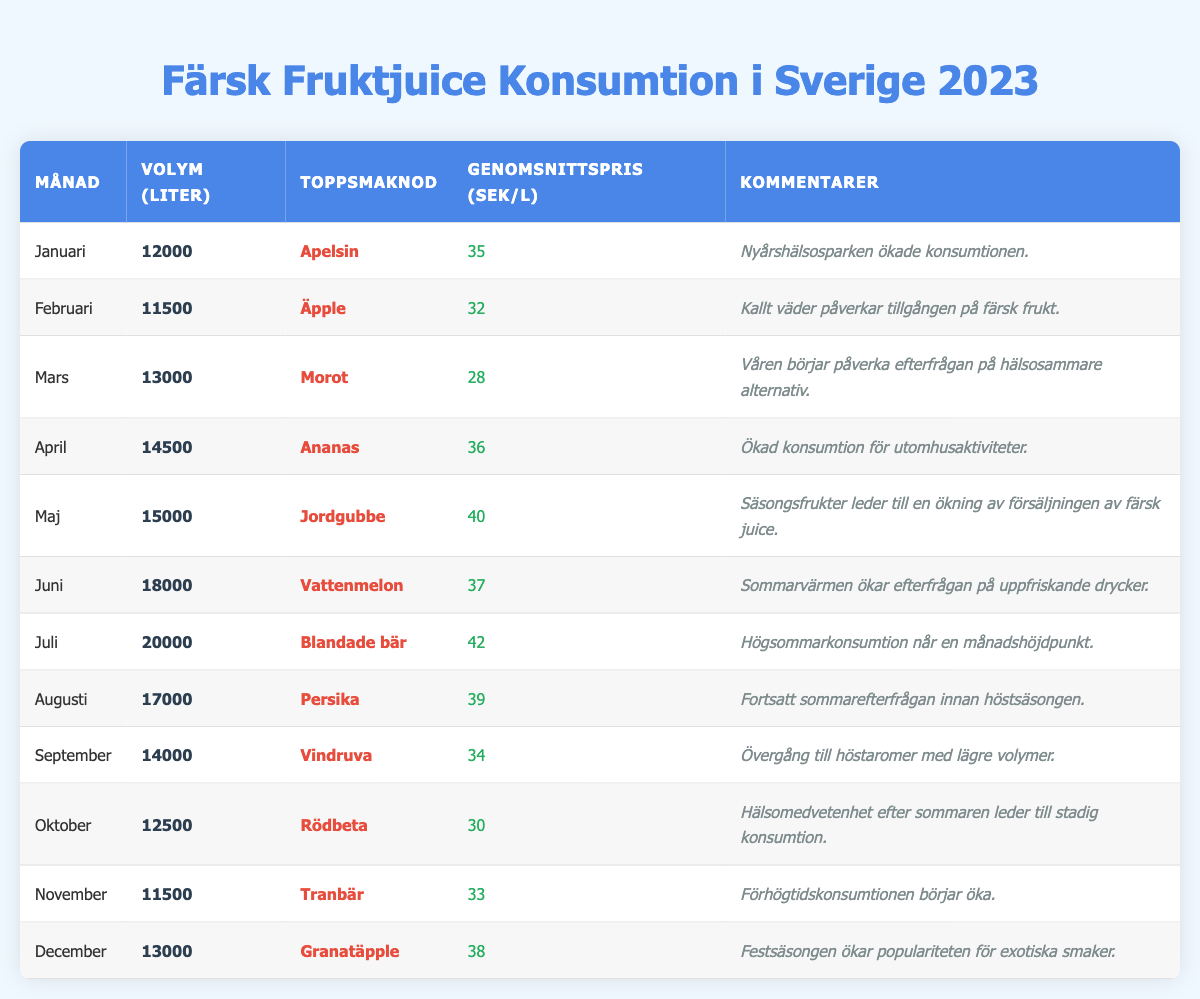What's the top flavor of fruit juice consumed in June? According to the table, the month of June lists "Watermelon" as the top flavor.
Answer: Watermelon How much fresh fruit juice was consumed in April? The table shows that the volume of fresh fruit juice consumed in April was 14,500 liters.
Answer: 14,500 liters What was the average price per liter of juice in October? The table indicates the average price per liter in October was 30 SEK.
Answer: 30 SEK Which month saw the highest juice consumption in terms of volume? Looking at the data, July had the highest consumption with 20,000 liters.
Answer: July What was the average price per liter for fresh fruit juice from January to March? To find the average, calculate the total price for January (35), February (32), and March (28): (35 + 32 + 28) = 95. Then, divide by 3 to get the average: 95 / 3 = approximately 31.67.
Answer: 31.67 SEK Did the consumption of fresh fruit juice increase from June to July? Comparing the volumes, June had 18,000 liters and July had 20,000 liters, so yes, consumption did increase.
Answer: Yes Which flavor was the least popular in February? The table lists "Apple" as the top flavor for February, indicating it was the only one listed for that month, thus it was the least popular overall.
Answer: Apple How much juice was consumed in total for the months of March, April, and May combined? Add the volumes from March (13,000), April (14,500), and May (15,000): 13,000 + 14,500 + 15,000 = 42,500 liters.
Answer: 42,500 liters Was there a trend of increasing prices for fresh fruit juices from January to July? Reviewing the average prices, they are: January (35), February (32), March (28), April (36), May (40), June (37), July (42). The prices initially fluctuated before rising towards July, indicating an upward trend.
Answer: Yes What comment appears for the month of May? The comment for May states, "Seasonal fruits lead to a spike in fresh juice sales."
Answer: Seasonal fruits lead to a spike in fresh juice sales What was the total volume of fresh fruit juice consumed in the second half of the year (July to December)? Calculate the total by summing the volumes from July (20,000), August (17,000), September (14,000), October (12,500), November (11,500), and December (13,000): 20,000 + 17,000 + 14,000 + 12,500 + 11,500 + 13,000 = 88,000 liters.
Answer: 88,000 liters 